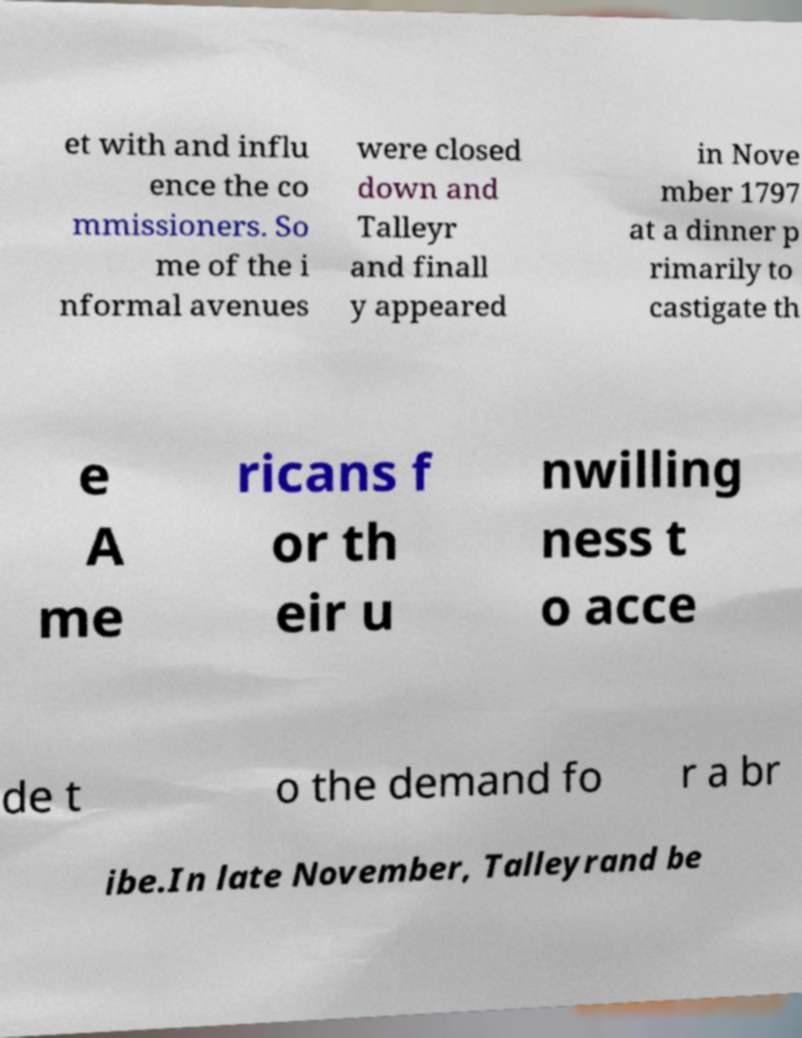Please identify and transcribe the text found in this image. et with and influ ence the co mmissioners. So me of the i nformal avenues were closed down and Talleyr and finall y appeared in Nove mber 1797 at a dinner p rimarily to castigate th e A me ricans f or th eir u nwilling ness t o acce de t o the demand fo r a br ibe.In late November, Talleyrand be 